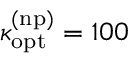<formula> <loc_0><loc_0><loc_500><loc_500>\kappa _ { o p t } ^ { ( n p ) } = 1 0 0</formula> 